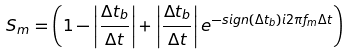Convert formula to latex. <formula><loc_0><loc_0><loc_500><loc_500>S _ { m } = \left ( 1 - \left | \frac { \Delta t _ { b } } { \Delta t } \right | + \left | \frac { \Delta t _ { b } } { \Delta t } \right | e ^ { - s i g n ( \Delta t _ { b } ) i 2 \pi f _ { m } \Delta t } \right )</formula> 